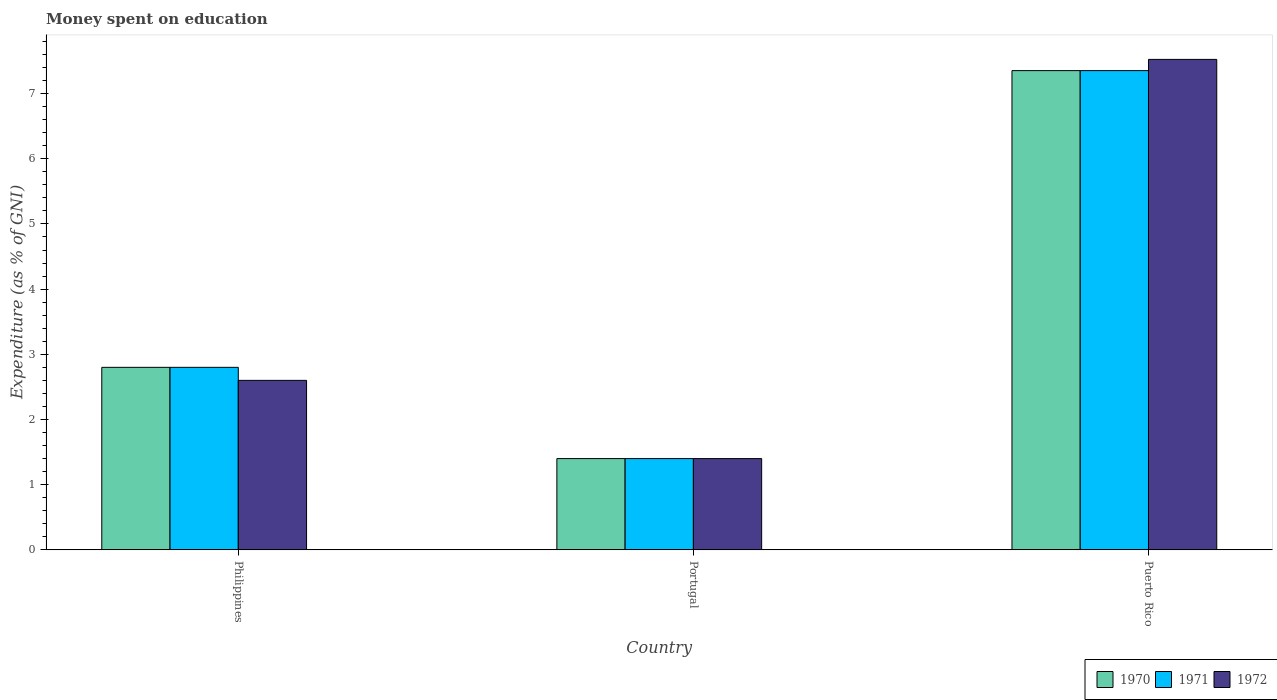Are the number of bars per tick equal to the number of legend labels?
Give a very brief answer. Yes. Across all countries, what is the maximum amount of money spent on education in 1971?
Offer a very short reply. 7.35. Across all countries, what is the minimum amount of money spent on education in 1970?
Your answer should be very brief. 1.4. In which country was the amount of money spent on education in 1972 maximum?
Your answer should be compact. Puerto Rico. In which country was the amount of money spent on education in 1970 minimum?
Offer a very short reply. Portugal. What is the total amount of money spent on education in 1972 in the graph?
Ensure brevity in your answer.  11.52. What is the difference between the amount of money spent on education in 1970 in Portugal and that in Puerto Rico?
Offer a very short reply. -5.95. What is the difference between the amount of money spent on education in 1970 in Portugal and the amount of money spent on education in 1971 in Philippines?
Give a very brief answer. -1.4. What is the average amount of money spent on education in 1972 per country?
Offer a very short reply. 3.84. What is the difference between the amount of money spent on education of/in 1972 and amount of money spent on education of/in 1970 in Philippines?
Provide a succinct answer. -0.2. In how many countries, is the amount of money spent on education in 1970 greater than 4.4 %?
Offer a very short reply. 1. What is the ratio of the amount of money spent on education in 1972 in Philippines to that in Puerto Rico?
Give a very brief answer. 0.35. Is the difference between the amount of money spent on education in 1972 in Philippines and Puerto Rico greater than the difference between the amount of money spent on education in 1970 in Philippines and Puerto Rico?
Offer a terse response. No. What is the difference between the highest and the second highest amount of money spent on education in 1972?
Ensure brevity in your answer.  -1.2. What is the difference between the highest and the lowest amount of money spent on education in 1970?
Keep it short and to the point. 5.95. Is the sum of the amount of money spent on education in 1970 in Philippines and Puerto Rico greater than the maximum amount of money spent on education in 1971 across all countries?
Your answer should be compact. Yes. What does the 2nd bar from the right in Puerto Rico represents?
Offer a very short reply. 1971. How many countries are there in the graph?
Give a very brief answer. 3. What is the difference between two consecutive major ticks on the Y-axis?
Your response must be concise. 1. Are the values on the major ticks of Y-axis written in scientific E-notation?
Ensure brevity in your answer.  No. Does the graph contain grids?
Give a very brief answer. No. Where does the legend appear in the graph?
Your response must be concise. Bottom right. How many legend labels are there?
Keep it short and to the point. 3. What is the title of the graph?
Keep it short and to the point. Money spent on education. What is the label or title of the Y-axis?
Your answer should be compact. Expenditure (as % of GNI). What is the Expenditure (as % of GNI) in 1972 in Philippines?
Your answer should be very brief. 2.6. What is the Expenditure (as % of GNI) of 1972 in Portugal?
Provide a short and direct response. 1.4. What is the Expenditure (as % of GNI) in 1970 in Puerto Rico?
Your response must be concise. 7.35. What is the Expenditure (as % of GNI) of 1971 in Puerto Rico?
Provide a succinct answer. 7.35. What is the Expenditure (as % of GNI) of 1972 in Puerto Rico?
Ensure brevity in your answer.  7.52. Across all countries, what is the maximum Expenditure (as % of GNI) of 1970?
Your answer should be very brief. 7.35. Across all countries, what is the maximum Expenditure (as % of GNI) in 1971?
Offer a very short reply. 7.35. Across all countries, what is the maximum Expenditure (as % of GNI) of 1972?
Provide a succinct answer. 7.52. Across all countries, what is the minimum Expenditure (as % of GNI) of 1971?
Ensure brevity in your answer.  1.4. Across all countries, what is the minimum Expenditure (as % of GNI) of 1972?
Your response must be concise. 1.4. What is the total Expenditure (as % of GNI) in 1970 in the graph?
Make the answer very short. 11.55. What is the total Expenditure (as % of GNI) of 1971 in the graph?
Your answer should be very brief. 11.55. What is the total Expenditure (as % of GNI) in 1972 in the graph?
Your answer should be compact. 11.52. What is the difference between the Expenditure (as % of GNI) in 1972 in Philippines and that in Portugal?
Ensure brevity in your answer.  1.2. What is the difference between the Expenditure (as % of GNI) of 1970 in Philippines and that in Puerto Rico?
Offer a very short reply. -4.55. What is the difference between the Expenditure (as % of GNI) of 1971 in Philippines and that in Puerto Rico?
Provide a succinct answer. -4.55. What is the difference between the Expenditure (as % of GNI) of 1972 in Philippines and that in Puerto Rico?
Provide a succinct answer. -4.92. What is the difference between the Expenditure (as % of GNI) in 1970 in Portugal and that in Puerto Rico?
Offer a very short reply. -5.95. What is the difference between the Expenditure (as % of GNI) in 1971 in Portugal and that in Puerto Rico?
Give a very brief answer. -5.95. What is the difference between the Expenditure (as % of GNI) in 1972 in Portugal and that in Puerto Rico?
Your answer should be compact. -6.12. What is the difference between the Expenditure (as % of GNI) in 1970 in Philippines and the Expenditure (as % of GNI) in 1971 in Portugal?
Offer a terse response. 1.4. What is the difference between the Expenditure (as % of GNI) in 1970 in Philippines and the Expenditure (as % of GNI) in 1972 in Portugal?
Keep it short and to the point. 1.4. What is the difference between the Expenditure (as % of GNI) in 1971 in Philippines and the Expenditure (as % of GNI) in 1972 in Portugal?
Your answer should be very brief. 1.4. What is the difference between the Expenditure (as % of GNI) in 1970 in Philippines and the Expenditure (as % of GNI) in 1971 in Puerto Rico?
Offer a very short reply. -4.55. What is the difference between the Expenditure (as % of GNI) of 1970 in Philippines and the Expenditure (as % of GNI) of 1972 in Puerto Rico?
Your answer should be very brief. -4.72. What is the difference between the Expenditure (as % of GNI) in 1971 in Philippines and the Expenditure (as % of GNI) in 1972 in Puerto Rico?
Your answer should be compact. -4.72. What is the difference between the Expenditure (as % of GNI) of 1970 in Portugal and the Expenditure (as % of GNI) of 1971 in Puerto Rico?
Ensure brevity in your answer.  -5.95. What is the difference between the Expenditure (as % of GNI) of 1970 in Portugal and the Expenditure (as % of GNI) of 1972 in Puerto Rico?
Provide a succinct answer. -6.12. What is the difference between the Expenditure (as % of GNI) in 1971 in Portugal and the Expenditure (as % of GNI) in 1972 in Puerto Rico?
Keep it short and to the point. -6.12. What is the average Expenditure (as % of GNI) of 1970 per country?
Offer a terse response. 3.85. What is the average Expenditure (as % of GNI) in 1971 per country?
Offer a very short reply. 3.85. What is the average Expenditure (as % of GNI) in 1972 per country?
Your answer should be compact. 3.84. What is the difference between the Expenditure (as % of GNI) of 1970 and Expenditure (as % of GNI) of 1971 in Philippines?
Ensure brevity in your answer.  0. What is the difference between the Expenditure (as % of GNI) of 1971 and Expenditure (as % of GNI) of 1972 in Philippines?
Your answer should be compact. 0.2. What is the difference between the Expenditure (as % of GNI) in 1970 and Expenditure (as % of GNI) in 1971 in Portugal?
Give a very brief answer. 0. What is the difference between the Expenditure (as % of GNI) of 1970 and Expenditure (as % of GNI) of 1972 in Portugal?
Your answer should be compact. 0. What is the difference between the Expenditure (as % of GNI) of 1971 and Expenditure (as % of GNI) of 1972 in Portugal?
Ensure brevity in your answer.  0. What is the difference between the Expenditure (as % of GNI) in 1970 and Expenditure (as % of GNI) in 1972 in Puerto Rico?
Your answer should be compact. -0.17. What is the difference between the Expenditure (as % of GNI) of 1971 and Expenditure (as % of GNI) of 1972 in Puerto Rico?
Give a very brief answer. -0.17. What is the ratio of the Expenditure (as % of GNI) of 1972 in Philippines to that in Portugal?
Your answer should be very brief. 1.86. What is the ratio of the Expenditure (as % of GNI) of 1970 in Philippines to that in Puerto Rico?
Keep it short and to the point. 0.38. What is the ratio of the Expenditure (as % of GNI) of 1971 in Philippines to that in Puerto Rico?
Keep it short and to the point. 0.38. What is the ratio of the Expenditure (as % of GNI) of 1972 in Philippines to that in Puerto Rico?
Give a very brief answer. 0.35. What is the ratio of the Expenditure (as % of GNI) in 1970 in Portugal to that in Puerto Rico?
Offer a terse response. 0.19. What is the ratio of the Expenditure (as % of GNI) of 1971 in Portugal to that in Puerto Rico?
Your response must be concise. 0.19. What is the ratio of the Expenditure (as % of GNI) of 1972 in Portugal to that in Puerto Rico?
Offer a very short reply. 0.19. What is the difference between the highest and the second highest Expenditure (as % of GNI) of 1970?
Keep it short and to the point. 4.55. What is the difference between the highest and the second highest Expenditure (as % of GNI) in 1971?
Your response must be concise. 4.55. What is the difference between the highest and the second highest Expenditure (as % of GNI) in 1972?
Give a very brief answer. 4.92. What is the difference between the highest and the lowest Expenditure (as % of GNI) in 1970?
Offer a terse response. 5.95. What is the difference between the highest and the lowest Expenditure (as % of GNI) of 1971?
Offer a terse response. 5.95. What is the difference between the highest and the lowest Expenditure (as % of GNI) in 1972?
Give a very brief answer. 6.12. 